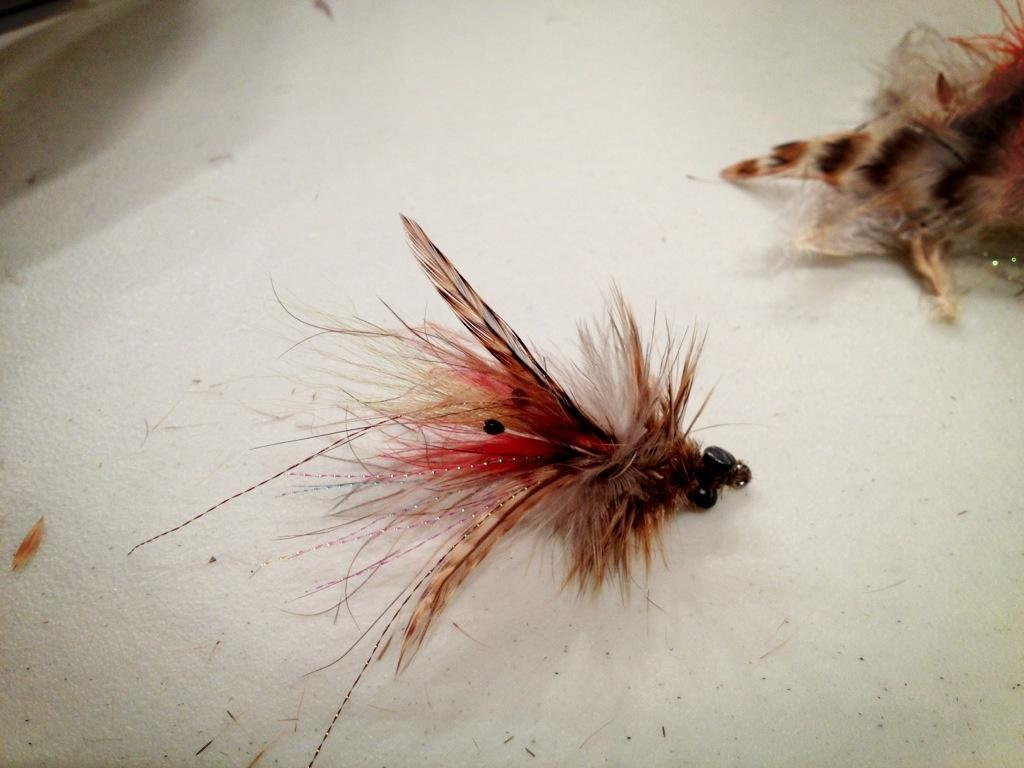What type of objects are present in the image? There are two artificial insects in the image. What is the color of the cloth on which the insects are placed? The artificial insects are on a white color cloth. What country is depicted in the image? There is no country depicted in the image; it features two artificial insects on a white cloth. What type of jelly can be seen surrounding the insects in the image? There is no jelly present in the image; it only features artificial insects on a white cloth. 